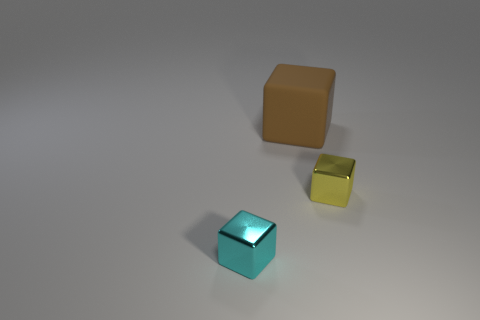What color is the tiny shiny object that is right of the tiny metallic cube that is in front of the tiny yellow object?
Your response must be concise. Yellow. There is another object that is the same size as the yellow thing; what is its color?
Provide a succinct answer. Cyan. Is there another small metal object of the same shape as the yellow metallic object?
Offer a terse response. Yes. What shape is the yellow metal object?
Your answer should be very brief. Cube. Are there more small metallic things to the right of the brown rubber block than rubber cubes that are on the right side of the yellow metallic cube?
Give a very brief answer. Yes. What number of other objects are there of the same size as the yellow cube?
Offer a very short reply. 1. What is the material of the cube that is both on the left side of the tiny yellow shiny thing and right of the small cyan metallic cube?
Give a very brief answer. Rubber. There is a tiny cyan object that is the same shape as the big matte thing; what is it made of?
Your answer should be very brief. Metal. How many cyan cubes are left of the thing that is in front of the tiny metal thing to the right of the big thing?
Provide a succinct answer. 0. Is there any other thing that is the same color as the big thing?
Your answer should be very brief. No. 